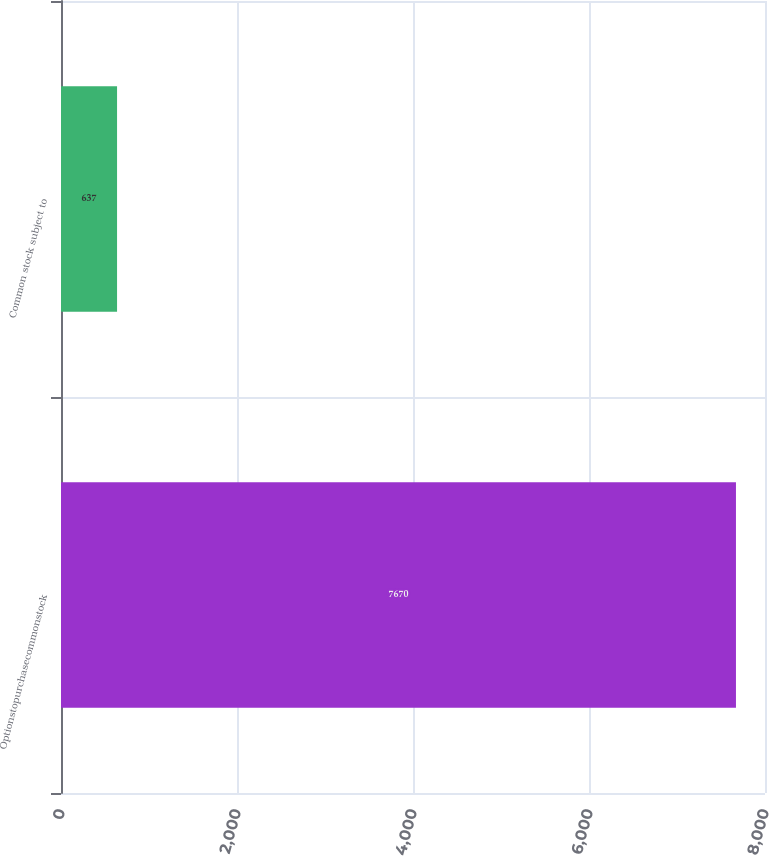Convert chart. <chart><loc_0><loc_0><loc_500><loc_500><bar_chart><fcel>Optionstopurchasecommonstock<fcel>Common stock subject to<nl><fcel>7670<fcel>637<nl></chart> 